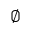Convert formula to latex. <formula><loc_0><loc_0><loc_500><loc_500>\emptyset</formula> 